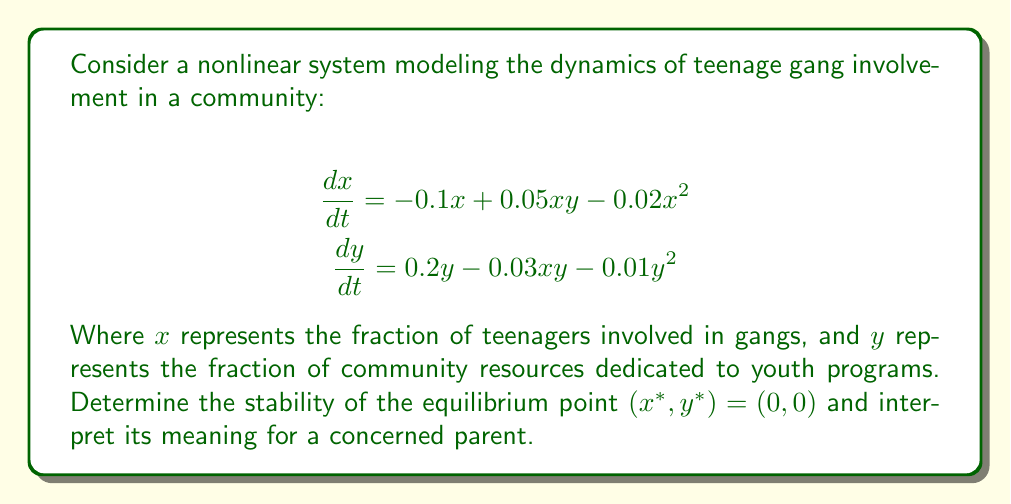What is the answer to this math problem? To analyze the stability of the equilibrium point $(0, 0)$, we need to linearize the system around this point and examine the eigenvalues of the Jacobian matrix.

Step 1: Calculate the Jacobian matrix at $(x, y)$:
$$J = \begin{bmatrix}
\frac{\partial f_1}{\partial x} & \frac{\partial f_1}{\partial y} \\
\frac{\partial f_2}{\partial x} & \frac{\partial f_2}{\partial y}
\end{bmatrix} = \begin{bmatrix}
-0.1 + 0.05y - 0.04x & 0.05x \\
-0.03y & 0.2 - 0.03x - 0.02y
\end{bmatrix}$$

Step 2: Evaluate the Jacobian at $(0, 0)$:
$$J(0, 0) = \begin{bmatrix}
-0.1 & 0 \\
0 & 0.2
\end{bmatrix}$$

Step 3: Calculate the eigenvalues of $J(0, 0)$:
$$\det(J(0, 0) - \lambda I) = \begin{vmatrix}
-0.1 - \lambda & 0 \\
0 & 0.2 - \lambda
\end{vmatrix} = (-0.1 - \lambda)(0.2 - \lambda) = 0$$

Solving this equation gives us the eigenvalues:
$$\lambda_1 = -0.1, \lambda_2 = 0.2$$

Step 4: Interpret the results:
Since we have one negative eigenvalue $(-0.1)$ and one positive eigenvalue $(0.2)$, the equilibrium point $(0, 0)$ is an unstable saddle point.

For a concerned parent, this means that the situation where no teenagers are involved in gangs and no community resources are dedicated to youth programs is inherently unstable. The positive eigenvalue indicates that without intervention, the system tends to move away from this state, potentially leading to an increase in gang involvement. The negative eigenvalue suggests that there's also a tendency for the system to move towards this state, which could represent the natural resistance to gang formation.

This instability emphasizes the importance of dedicating community resources to youth programs $(y > 0)$ to prevent the growth of gang involvement among teenagers.
Answer: Unstable saddle point 